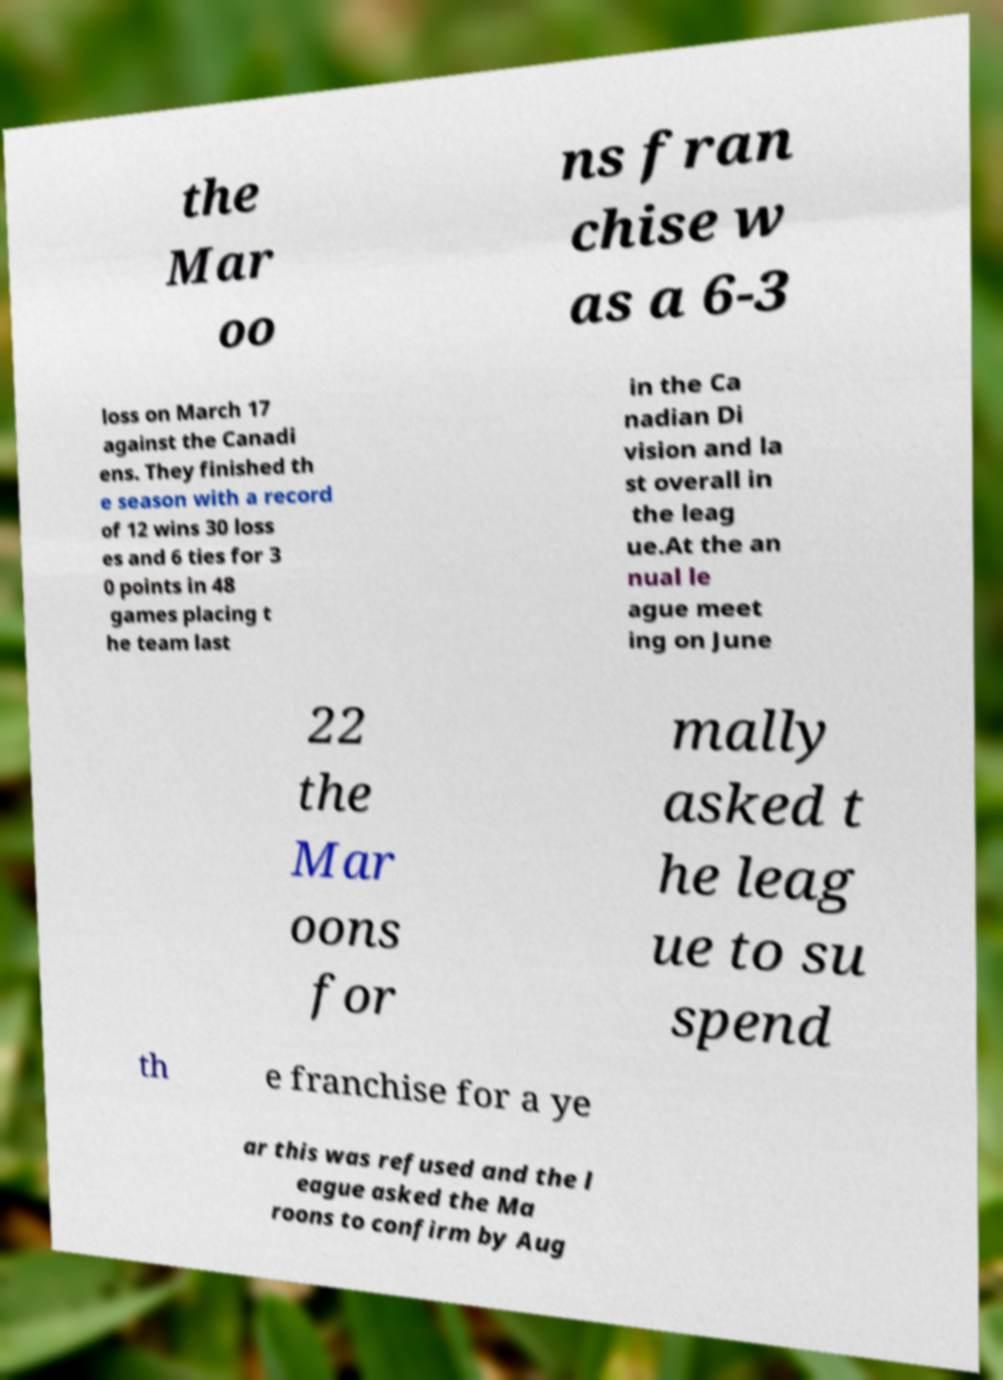Please read and relay the text visible in this image. What does it say? the Mar oo ns fran chise w as a 6-3 loss on March 17 against the Canadi ens. They finished th e season with a record of 12 wins 30 loss es and 6 ties for 3 0 points in 48 games placing t he team last in the Ca nadian Di vision and la st overall in the leag ue.At the an nual le ague meet ing on June 22 the Mar oons for mally asked t he leag ue to su spend th e franchise for a ye ar this was refused and the l eague asked the Ma roons to confirm by Aug 